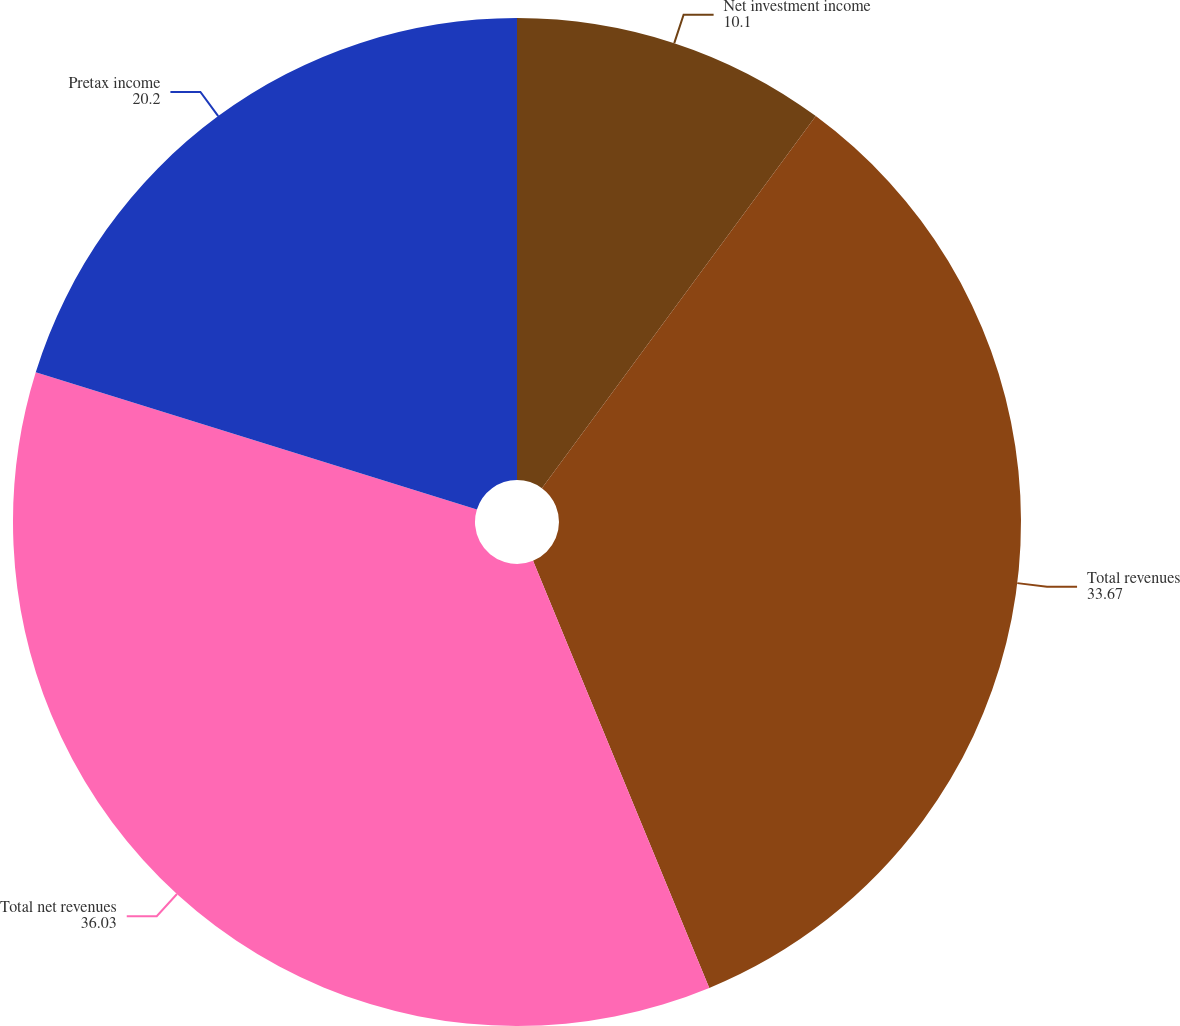Convert chart. <chart><loc_0><loc_0><loc_500><loc_500><pie_chart><fcel>Net investment income<fcel>Total revenues<fcel>Total net revenues<fcel>Pretax income<nl><fcel>10.1%<fcel>33.67%<fcel>36.03%<fcel>20.2%<nl></chart> 